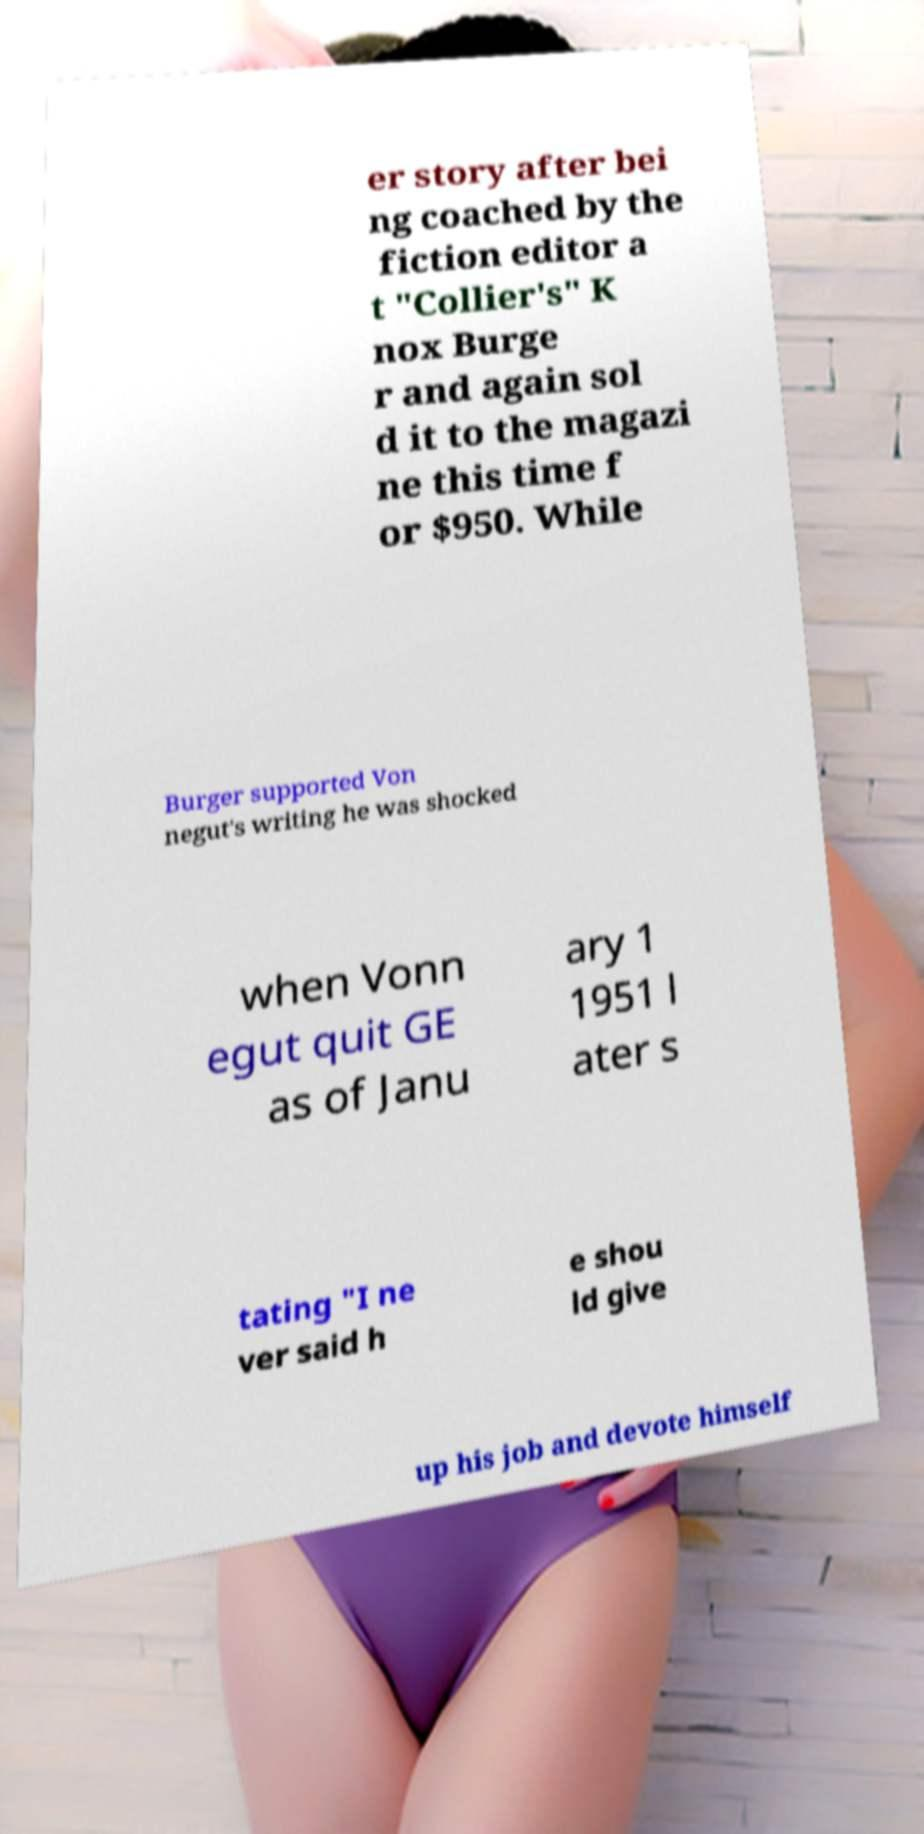Can you read and provide the text displayed in the image?This photo seems to have some interesting text. Can you extract and type it out for me? er story after bei ng coached by the fiction editor a t "Collier's" K nox Burge r and again sol d it to the magazi ne this time f or $950. While Burger supported Von negut's writing he was shocked when Vonn egut quit GE as of Janu ary 1 1951 l ater s tating "I ne ver said h e shou ld give up his job and devote himself 